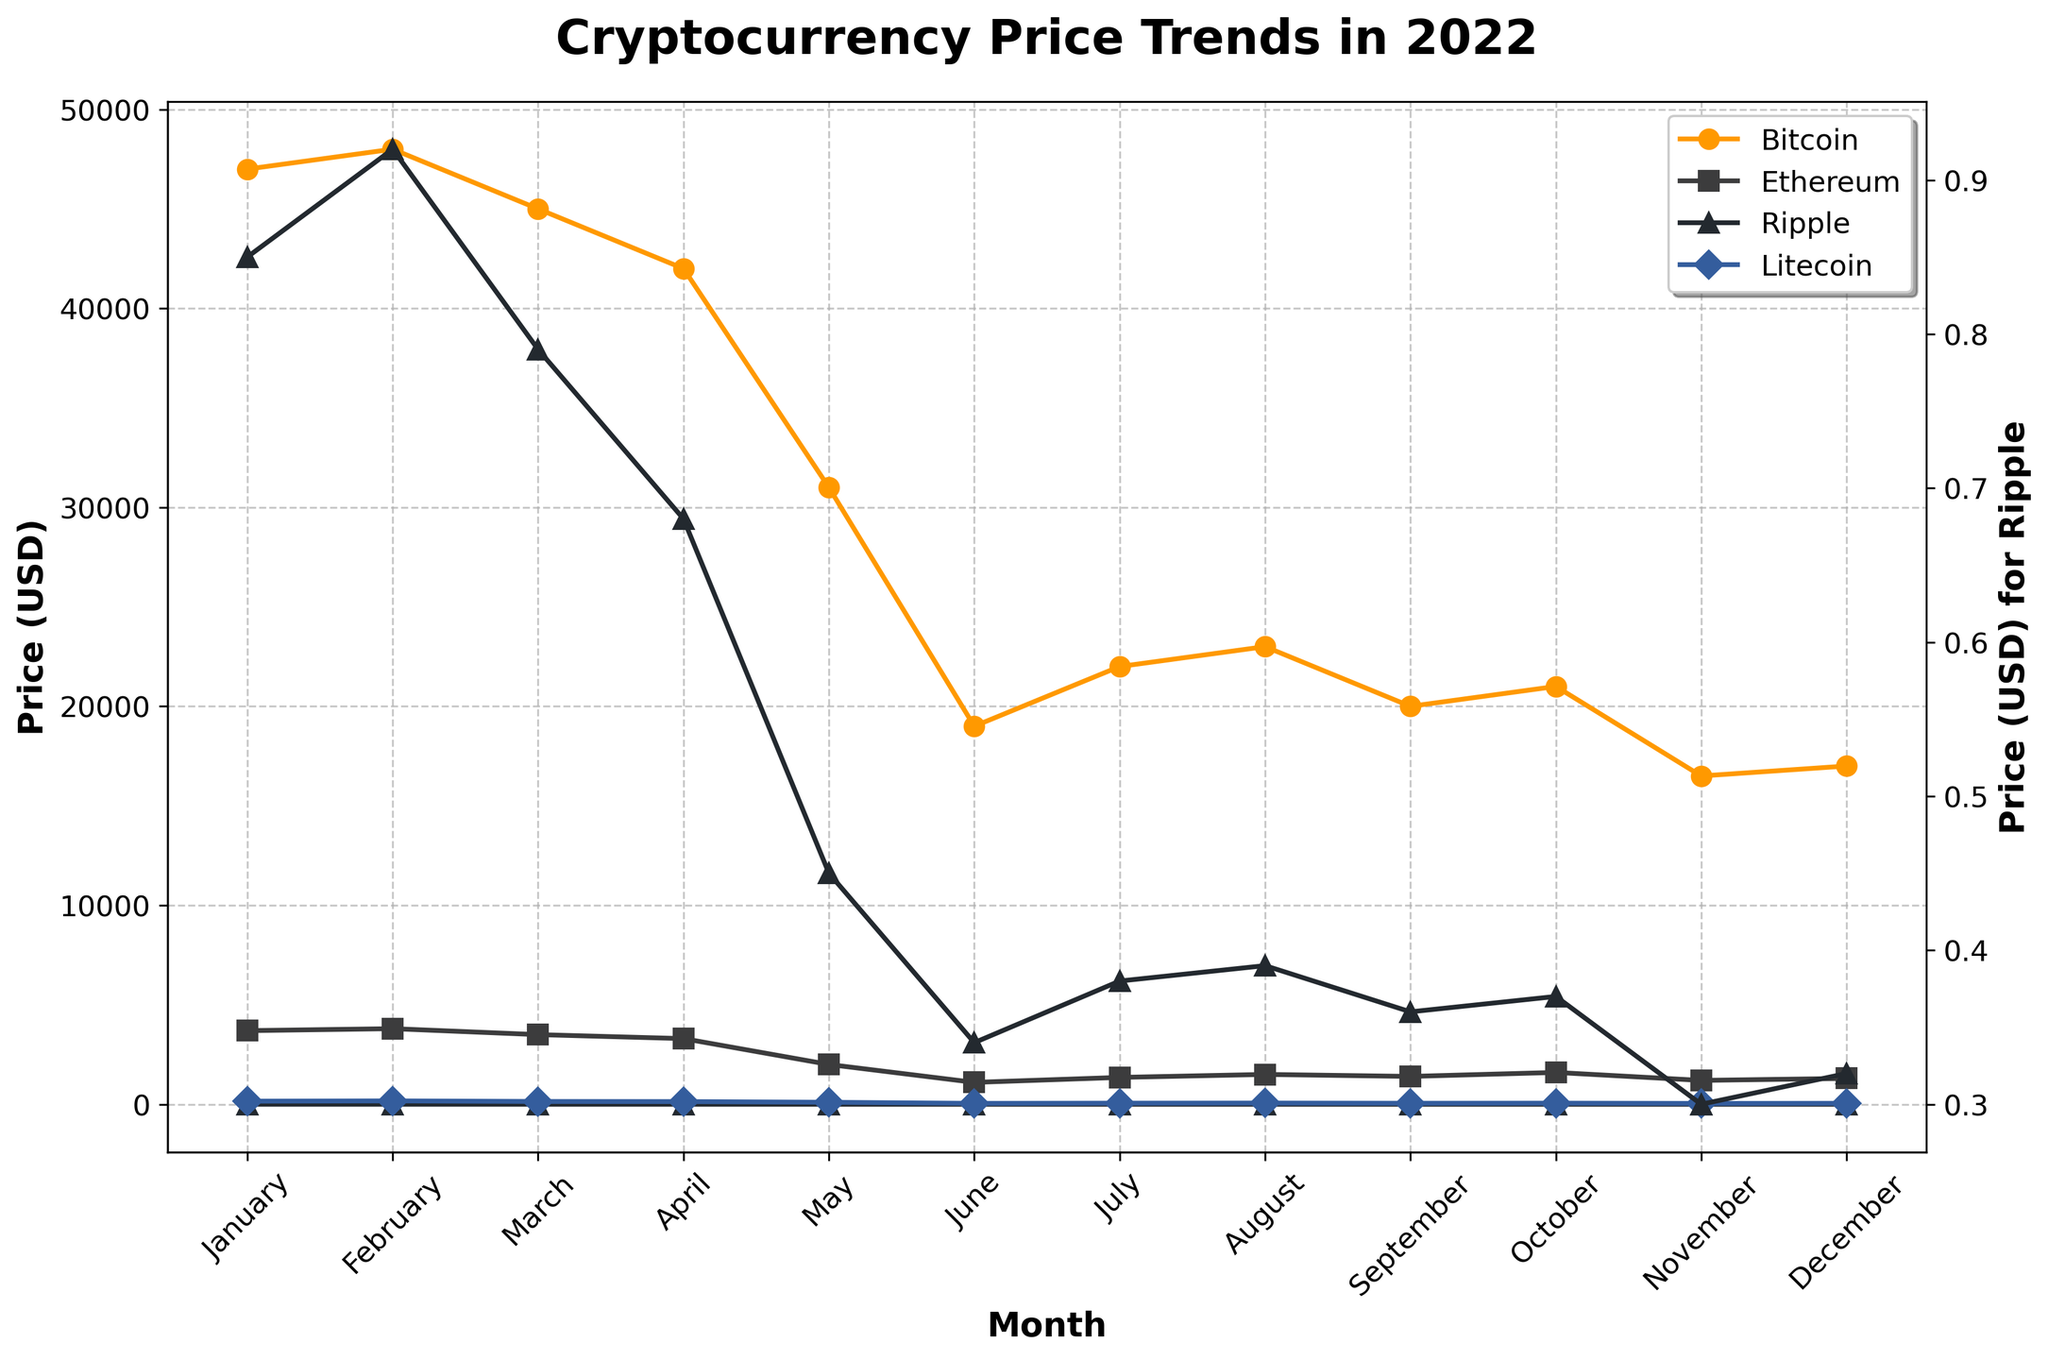What is the title of the figure? The title is at the top of the figure in a large, bold font. The title reads "Cryptocurrency Price Trends in 2022".
Answer: Cryptocurrency Price Trends in 2022 Which cryptocurrency experienced the largest drop in price from January to December? To find the largest drop, look at the prices in January and December for each currency. Compare the differences: Bitcoin (47000-17000), Ethereum (3700-1300), Ripple (0.85-0.32), and Litecoin (155-48). Bitcoin's drop is the largest.
Answer: Bitcoin What is the average price of Ethereum from January to June? To calculate the average, sum Ethereum's prices from January to June and divide by 6. (3700+3800+3500+3300+2000+1100)/6 = 2900
Answer: 2900 Which months did Ripple have the lowest prices? Look at the plot for Ripple (0.32, 0.30, 0.32) to identify the lowest points. The lowest prices are in June, November, and December.
Answer: June, November, December How did the price of Litecoin change from February to March? Compare Litecoin's price in February (170) and March (140). Subtract March's price from February's price to find the change (170 - 140 = 30).
Answer: -30 In which month did Bitcoin price first dip below $20,000? Track Bitcoin's prices month-by-month on the plot. The first month below $20,000 is June ($19,000).
Answer: June Which cryptocurrency showed the most consistent price trend throughout the year? Observe the trends for each cryptocurrency from January to December. Ripple shows a more consistent declining trend without sharp fluctuations compared to others.
Answer: Ripple What was the highest price of Litecoin during the year? Check the plot for Litecoin's highest point, which is in February with a peak price of $170.
Answer: 170 Compare the October and November prices of Ethereum. How much did it fall? Calculate the difference between October and November prices for Ethereum (1600 - 1200). The fall is 400.
Answer: 400 